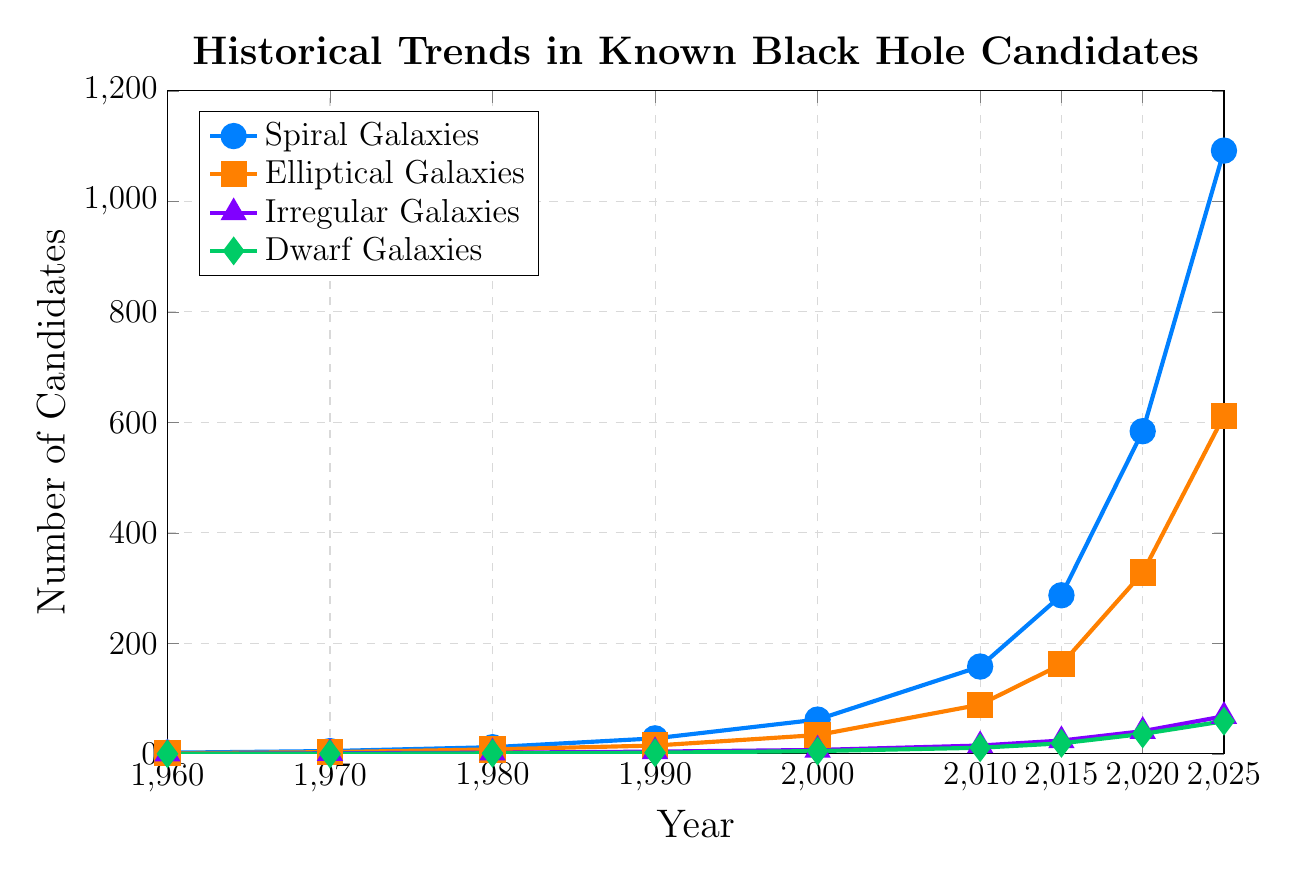What is the general trend observed in the number of known black hole candidates in Spiral Galaxies from 1960 to 2025? The number of known black hole candidates in Spiral Galaxies consistently increases over time, starting from 2 in 1960 and reaching 1092 in 2025. This shows a steady upward trend.
Answer: An increasing trend Which galaxy type had the most known black hole candidates in the year 2000? For the year 2000, the known black hole candidates are as follows: Spiral Galaxies (62), Elliptical Galaxies (34), Irregular Galaxies (7), and Dwarf Galaxies (5). Therefore, Spiral Galaxies had the most known candidates.
Answer: Spiral Galaxies How many total black hole candidates were known across all galaxy types in 2015? Summing the numbers for each galaxy type in 2015 - Spiral Galaxies (287), Elliptical Galaxies (162), Irregular Galaxies (24), and Dwarf Galaxies (19) - we get: 287 + 162 + 24 + 19 = 492.
Answer: 492 By how much did the number of known black hole candidates in Elliptical Galaxies increase from 1960 to 2025? The number of known candidates in Elliptical Galaxies was 1 in 1960 and 612 in 2025. The increase can be calculated as 612 - 1 = 611.
Answer: 611 Which two galaxy types had the most similar number of known black hole candidates in the year 1980? In 1980, known candidates were: Spiral Galaxies (12), Elliptical Galaxies (8), Irregular Galaxies (2), and Dwarf Galaxies (1). The closest values are between Irregular Galaxies (2) and Dwarf Galaxies (1).
Answer: Irregular and Dwarf Galaxies Between which consecutive decades did Spiral Galaxies see the highest increase in the number of known black hole candidates? Analyzing the differences: 
1960-1970: 5-2 = 3
1970-1980: 12-5 = 7
1980-1990: 28-12 = 16
1990-2000: 62-28 = 34
2000-2010: 158-62 = 96
2010-2015: 287-158 = 129
2015-2020: 584-287 = 297
2020-2025: 1092-584 = 508
The largest increase happened between 2020-2025 (508 candidates).
Answer: Between 2020 and 2025 In which year did Irregular Galaxies first exceed 10 known black hole candidates? The number of known black hole candidates for Irregular Galaxies first exceeds 10 in the year 2010, reaching 15 candidates.
Answer: 2010 Compare the growth rate of known black hole candidates between 2010 and 2025 for Spiral Galaxies and Elliptical Galaxies. Which galaxy type had a steeper growth? Spiral Galaxies from 2010 to 2025 increased from 158 to 1092 (increase of 934). Elliptical Galaxies increased from 89 to 612 (increase of 523). The growth rate is higher for Spiral Galaxies (934) compared to Elliptical Galaxies (523).
Answer: Spiral Galaxies From 1970 to 1990, which galaxy type had the highest relative growth in the number of known black hole candidates? Relative growth is proportional increase:
- Spiral Galaxies: (28-5)/5 = 4.6
- Elliptical Galaxies: (15-3)/3 = 4
- Irregular Galaxies: (4-1)/1 = 3
- Dwarf Galaxies: (2-0)/0 = Not applicable
Spiral Galaxies had the highest relative growth rate (4.6 times increase).
Answer: Spiral Galaxies 